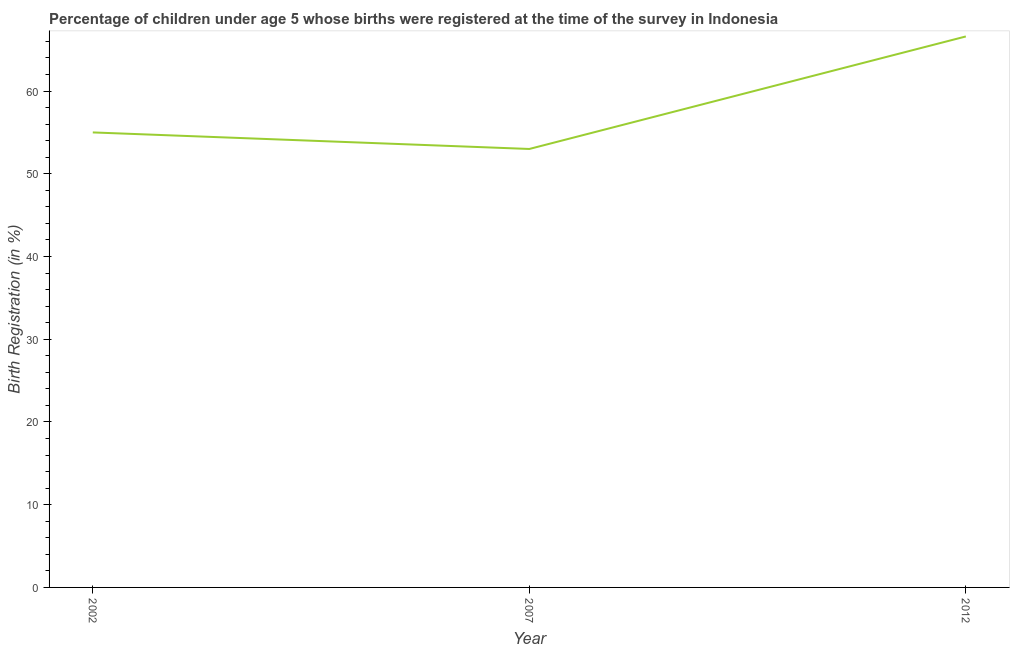What is the birth registration in 2002?
Provide a short and direct response. 55. Across all years, what is the maximum birth registration?
Your response must be concise. 66.6. In which year was the birth registration maximum?
Keep it short and to the point. 2012. What is the sum of the birth registration?
Your answer should be very brief. 174.6. What is the difference between the birth registration in 2002 and 2012?
Ensure brevity in your answer.  -11.6. What is the average birth registration per year?
Keep it short and to the point. 58.2. Do a majority of the years between 2012 and 2007 (inclusive) have birth registration greater than 8 %?
Make the answer very short. No. What is the ratio of the birth registration in 2007 to that in 2012?
Provide a short and direct response. 0.8. Is the difference between the birth registration in 2002 and 2007 greater than the difference between any two years?
Provide a succinct answer. No. What is the difference between the highest and the second highest birth registration?
Provide a short and direct response. 11.6. Is the sum of the birth registration in 2002 and 2007 greater than the maximum birth registration across all years?
Offer a very short reply. Yes. What is the difference between the highest and the lowest birth registration?
Your answer should be compact. 13.6. Does the birth registration monotonically increase over the years?
Ensure brevity in your answer.  No. How many lines are there?
Ensure brevity in your answer.  1. How many years are there in the graph?
Provide a short and direct response. 3. Does the graph contain any zero values?
Provide a succinct answer. No. What is the title of the graph?
Your answer should be compact. Percentage of children under age 5 whose births were registered at the time of the survey in Indonesia. What is the label or title of the X-axis?
Ensure brevity in your answer.  Year. What is the label or title of the Y-axis?
Keep it short and to the point. Birth Registration (in %). What is the Birth Registration (in %) in 2007?
Give a very brief answer. 53. What is the Birth Registration (in %) in 2012?
Offer a terse response. 66.6. What is the difference between the Birth Registration (in %) in 2002 and 2007?
Offer a very short reply. 2. What is the ratio of the Birth Registration (in %) in 2002 to that in 2007?
Offer a very short reply. 1.04. What is the ratio of the Birth Registration (in %) in 2002 to that in 2012?
Provide a short and direct response. 0.83. What is the ratio of the Birth Registration (in %) in 2007 to that in 2012?
Offer a terse response. 0.8. 